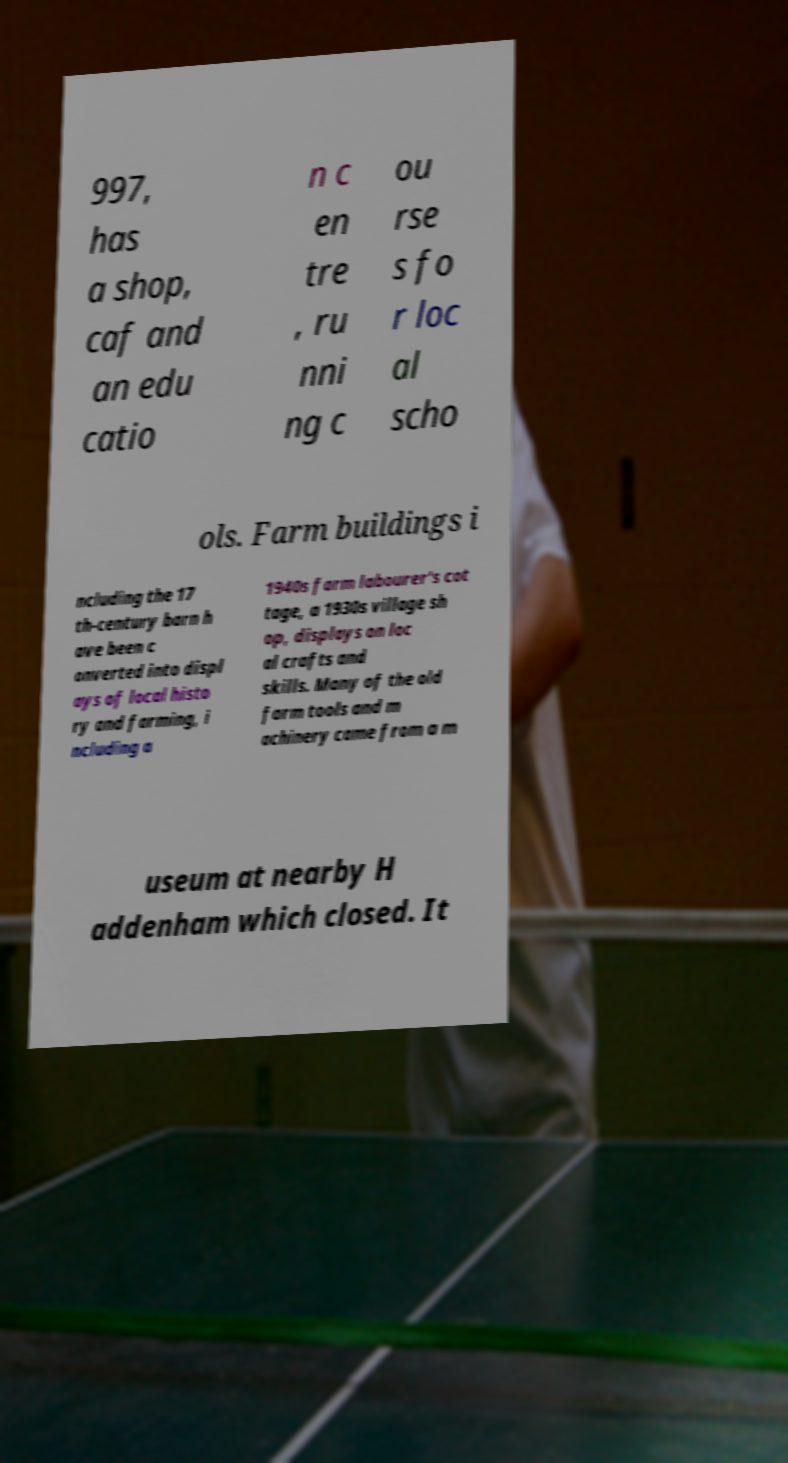Please read and relay the text visible in this image. What does it say? 997, has a shop, caf and an edu catio n c en tre , ru nni ng c ou rse s fo r loc al scho ols. Farm buildings i ncluding the 17 th-century barn h ave been c onverted into displ ays of local histo ry and farming, i ncluding a 1940s farm labourer's cot tage, a 1930s village sh op, displays on loc al crafts and skills. Many of the old farm tools and m achinery came from a m useum at nearby H addenham which closed. It 